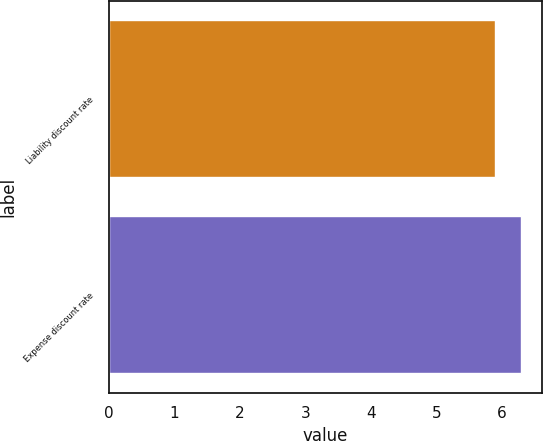<chart> <loc_0><loc_0><loc_500><loc_500><bar_chart><fcel>Liability discount rate<fcel>Expense discount rate<nl><fcel>5.9<fcel>6.3<nl></chart> 